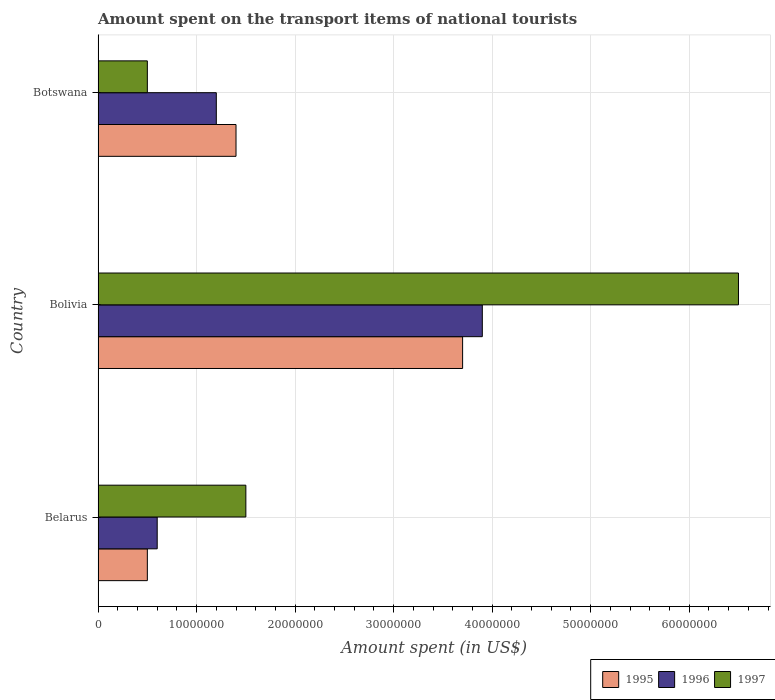How many different coloured bars are there?
Make the answer very short. 3. How many groups of bars are there?
Provide a short and direct response. 3. Are the number of bars on each tick of the Y-axis equal?
Your response must be concise. Yes. What is the amount spent on the transport items of national tourists in 1997 in Botswana?
Offer a terse response. 5.00e+06. Across all countries, what is the maximum amount spent on the transport items of national tourists in 1995?
Your answer should be very brief. 3.70e+07. In which country was the amount spent on the transport items of national tourists in 1995 maximum?
Provide a short and direct response. Bolivia. In which country was the amount spent on the transport items of national tourists in 1995 minimum?
Your answer should be compact. Belarus. What is the total amount spent on the transport items of national tourists in 1997 in the graph?
Make the answer very short. 8.50e+07. What is the difference between the amount spent on the transport items of national tourists in 1997 in Belarus and that in Bolivia?
Your response must be concise. -5.00e+07. What is the difference between the amount spent on the transport items of national tourists in 1996 in Bolivia and the amount spent on the transport items of national tourists in 1997 in Botswana?
Offer a very short reply. 3.40e+07. What is the average amount spent on the transport items of national tourists in 1997 per country?
Your answer should be very brief. 2.83e+07. What is the difference between the amount spent on the transport items of national tourists in 1997 and amount spent on the transport items of national tourists in 1996 in Belarus?
Make the answer very short. 9.00e+06. What is the ratio of the amount spent on the transport items of national tourists in 1996 in Belarus to that in Bolivia?
Offer a terse response. 0.15. Is the difference between the amount spent on the transport items of national tourists in 1997 in Bolivia and Botswana greater than the difference between the amount spent on the transport items of national tourists in 1996 in Bolivia and Botswana?
Keep it short and to the point. Yes. What is the difference between the highest and the second highest amount spent on the transport items of national tourists in 1995?
Provide a short and direct response. 2.30e+07. What is the difference between the highest and the lowest amount spent on the transport items of national tourists in 1997?
Your answer should be compact. 6.00e+07. Is the sum of the amount spent on the transport items of national tourists in 1995 in Belarus and Bolivia greater than the maximum amount spent on the transport items of national tourists in 1996 across all countries?
Your answer should be compact. Yes. What does the 3rd bar from the top in Belarus represents?
Your answer should be compact. 1995. What does the 2nd bar from the bottom in Belarus represents?
Your answer should be very brief. 1996. How many bars are there?
Ensure brevity in your answer.  9. Are the values on the major ticks of X-axis written in scientific E-notation?
Your answer should be very brief. No. Does the graph contain any zero values?
Keep it short and to the point. No. Does the graph contain grids?
Your response must be concise. Yes. Where does the legend appear in the graph?
Your answer should be very brief. Bottom right. How many legend labels are there?
Keep it short and to the point. 3. What is the title of the graph?
Provide a succinct answer. Amount spent on the transport items of national tourists. What is the label or title of the X-axis?
Offer a very short reply. Amount spent (in US$). What is the label or title of the Y-axis?
Offer a very short reply. Country. What is the Amount spent (in US$) of 1995 in Belarus?
Offer a very short reply. 5.00e+06. What is the Amount spent (in US$) of 1996 in Belarus?
Your answer should be compact. 6.00e+06. What is the Amount spent (in US$) of 1997 in Belarus?
Provide a succinct answer. 1.50e+07. What is the Amount spent (in US$) of 1995 in Bolivia?
Your answer should be compact. 3.70e+07. What is the Amount spent (in US$) in 1996 in Bolivia?
Provide a short and direct response. 3.90e+07. What is the Amount spent (in US$) of 1997 in Bolivia?
Make the answer very short. 6.50e+07. What is the Amount spent (in US$) of 1995 in Botswana?
Offer a very short reply. 1.40e+07. What is the Amount spent (in US$) of 1996 in Botswana?
Offer a very short reply. 1.20e+07. What is the Amount spent (in US$) in 1997 in Botswana?
Give a very brief answer. 5.00e+06. Across all countries, what is the maximum Amount spent (in US$) in 1995?
Ensure brevity in your answer.  3.70e+07. Across all countries, what is the maximum Amount spent (in US$) in 1996?
Your response must be concise. 3.90e+07. Across all countries, what is the maximum Amount spent (in US$) of 1997?
Give a very brief answer. 6.50e+07. Across all countries, what is the minimum Amount spent (in US$) of 1996?
Offer a terse response. 6.00e+06. Across all countries, what is the minimum Amount spent (in US$) in 1997?
Your answer should be very brief. 5.00e+06. What is the total Amount spent (in US$) in 1995 in the graph?
Give a very brief answer. 5.60e+07. What is the total Amount spent (in US$) of 1996 in the graph?
Your answer should be very brief. 5.70e+07. What is the total Amount spent (in US$) in 1997 in the graph?
Give a very brief answer. 8.50e+07. What is the difference between the Amount spent (in US$) of 1995 in Belarus and that in Bolivia?
Your response must be concise. -3.20e+07. What is the difference between the Amount spent (in US$) in 1996 in Belarus and that in Bolivia?
Your answer should be very brief. -3.30e+07. What is the difference between the Amount spent (in US$) of 1997 in Belarus and that in Bolivia?
Provide a succinct answer. -5.00e+07. What is the difference between the Amount spent (in US$) of 1995 in Belarus and that in Botswana?
Your answer should be very brief. -9.00e+06. What is the difference between the Amount spent (in US$) of 1996 in Belarus and that in Botswana?
Keep it short and to the point. -6.00e+06. What is the difference between the Amount spent (in US$) of 1997 in Belarus and that in Botswana?
Provide a succinct answer. 1.00e+07. What is the difference between the Amount spent (in US$) in 1995 in Bolivia and that in Botswana?
Give a very brief answer. 2.30e+07. What is the difference between the Amount spent (in US$) of 1996 in Bolivia and that in Botswana?
Give a very brief answer. 2.70e+07. What is the difference between the Amount spent (in US$) of 1997 in Bolivia and that in Botswana?
Provide a short and direct response. 6.00e+07. What is the difference between the Amount spent (in US$) of 1995 in Belarus and the Amount spent (in US$) of 1996 in Bolivia?
Your response must be concise. -3.40e+07. What is the difference between the Amount spent (in US$) in 1995 in Belarus and the Amount spent (in US$) in 1997 in Bolivia?
Your answer should be very brief. -6.00e+07. What is the difference between the Amount spent (in US$) in 1996 in Belarus and the Amount spent (in US$) in 1997 in Bolivia?
Keep it short and to the point. -5.90e+07. What is the difference between the Amount spent (in US$) in 1995 in Belarus and the Amount spent (in US$) in 1996 in Botswana?
Keep it short and to the point. -7.00e+06. What is the difference between the Amount spent (in US$) in 1995 in Bolivia and the Amount spent (in US$) in 1996 in Botswana?
Your answer should be compact. 2.50e+07. What is the difference between the Amount spent (in US$) in 1995 in Bolivia and the Amount spent (in US$) in 1997 in Botswana?
Give a very brief answer. 3.20e+07. What is the difference between the Amount spent (in US$) in 1996 in Bolivia and the Amount spent (in US$) in 1997 in Botswana?
Your response must be concise. 3.40e+07. What is the average Amount spent (in US$) in 1995 per country?
Provide a short and direct response. 1.87e+07. What is the average Amount spent (in US$) of 1996 per country?
Offer a very short reply. 1.90e+07. What is the average Amount spent (in US$) of 1997 per country?
Your answer should be compact. 2.83e+07. What is the difference between the Amount spent (in US$) in 1995 and Amount spent (in US$) in 1997 in Belarus?
Ensure brevity in your answer.  -1.00e+07. What is the difference between the Amount spent (in US$) of 1996 and Amount spent (in US$) of 1997 in Belarus?
Your answer should be very brief. -9.00e+06. What is the difference between the Amount spent (in US$) of 1995 and Amount spent (in US$) of 1996 in Bolivia?
Give a very brief answer. -2.00e+06. What is the difference between the Amount spent (in US$) of 1995 and Amount spent (in US$) of 1997 in Bolivia?
Your answer should be compact. -2.80e+07. What is the difference between the Amount spent (in US$) of 1996 and Amount spent (in US$) of 1997 in Bolivia?
Make the answer very short. -2.60e+07. What is the difference between the Amount spent (in US$) in 1995 and Amount spent (in US$) in 1997 in Botswana?
Make the answer very short. 9.00e+06. What is the difference between the Amount spent (in US$) in 1996 and Amount spent (in US$) in 1997 in Botswana?
Give a very brief answer. 7.00e+06. What is the ratio of the Amount spent (in US$) of 1995 in Belarus to that in Bolivia?
Provide a short and direct response. 0.14. What is the ratio of the Amount spent (in US$) in 1996 in Belarus to that in Bolivia?
Give a very brief answer. 0.15. What is the ratio of the Amount spent (in US$) in 1997 in Belarus to that in Bolivia?
Your answer should be compact. 0.23. What is the ratio of the Amount spent (in US$) in 1995 in Belarus to that in Botswana?
Your response must be concise. 0.36. What is the ratio of the Amount spent (in US$) of 1996 in Belarus to that in Botswana?
Your response must be concise. 0.5. What is the ratio of the Amount spent (in US$) of 1995 in Bolivia to that in Botswana?
Your response must be concise. 2.64. What is the ratio of the Amount spent (in US$) of 1997 in Bolivia to that in Botswana?
Your answer should be very brief. 13. What is the difference between the highest and the second highest Amount spent (in US$) in 1995?
Offer a terse response. 2.30e+07. What is the difference between the highest and the second highest Amount spent (in US$) in 1996?
Make the answer very short. 2.70e+07. What is the difference between the highest and the second highest Amount spent (in US$) in 1997?
Provide a succinct answer. 5.00e+07. What is the difference between the highest and the lowest Amount spent (in US$) in 1995?
Keep it short and to the point. 3.20e+07. What is the difference between the highest and the lowest Amount spent (in US$) of 1996?
Make the answer very short. 3.30e+07. What is the difference between the highest and the lowest Amount spent (in US$) in 1997?
Give a very brief answer. 6.00e+07. 